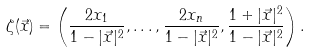Convert formula to latex. <formula><loc_0><loc_0><loc_500><loc_500>\zeta ( \vec { x } ) = \left ( \frac { 2 x _ { 1 } } { 1 - | \vec { x } | ^ { 2 } } , \dots , \frac { 2 x _ { n } } { 1 - | \vec { x } | ^ { 2 } } , \frac { 1 + | \vec { x } | ^ { 2 } } { 1 - | \vec { x } | ^ { 2 } } \right ) .</formula> 